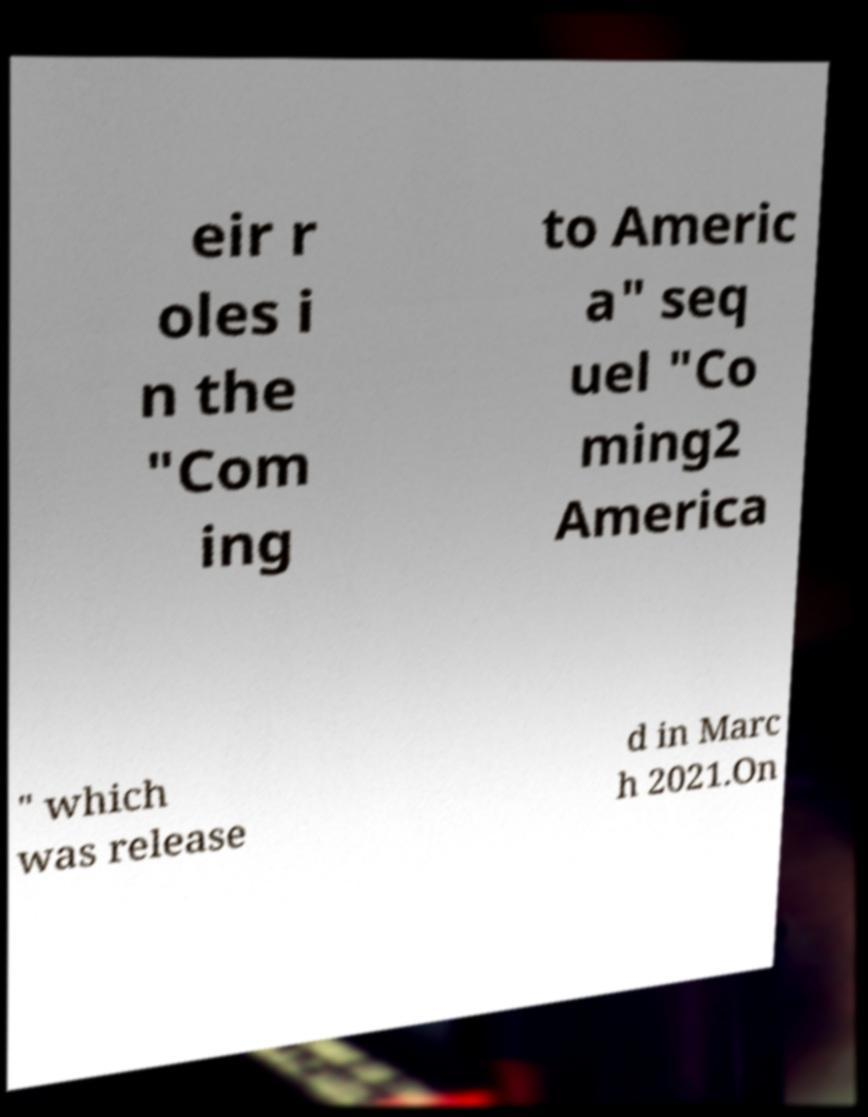Could you assist in decoding the text presented in this image and type it out clearly? eir r oles i n the "Com ing to Americ a" seq uel "Co ming2 America " which was release d in Marc h 2021.On 